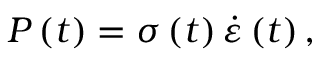Convert formula to latex. <formula><loc_0><loc_0><loc_500><loc_500>P \left ( t \right ) = \sigma \left ( t \right ) \dot { \varepsilon } \left ( t \right ) ,</formula> 